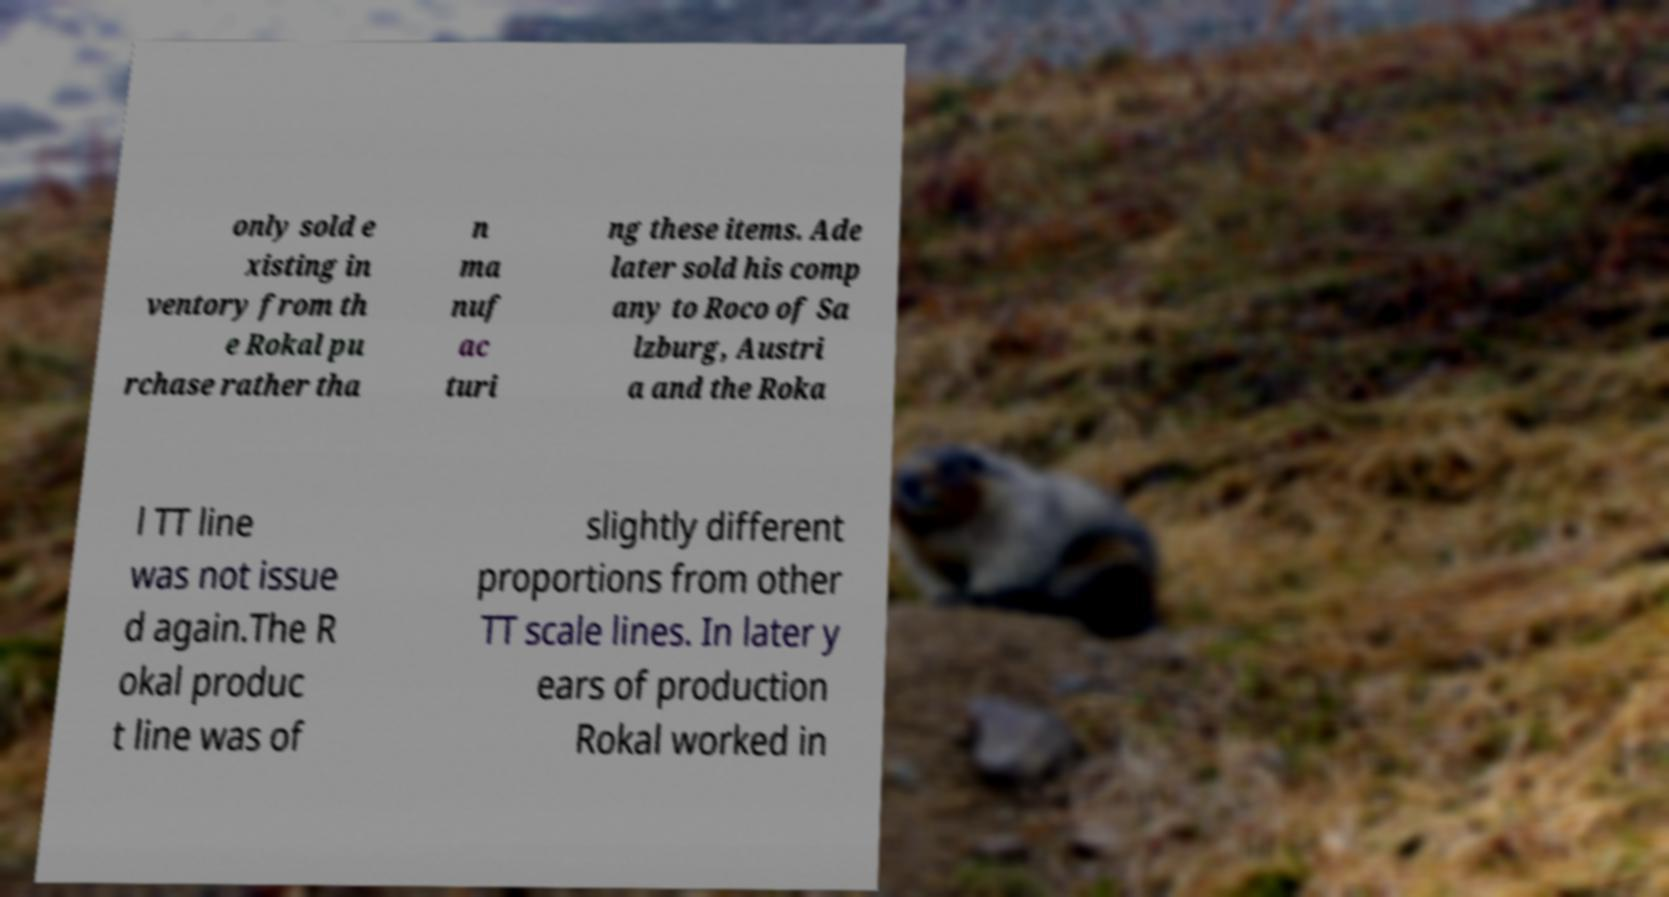Please read and relay the text visible in this image. What does it say? only sold e xisting in ventory from th e Rokal pu rchase rather tha n ma nuf ac turi ng these items. Ade later sold his comp any to Roco of Sa lzburg, Austri a and the Roka l TT line was not issue d again.The R okal produc t line was of slightly different proportions from other TT scale lines. In later y ears of production Rokal worked in 